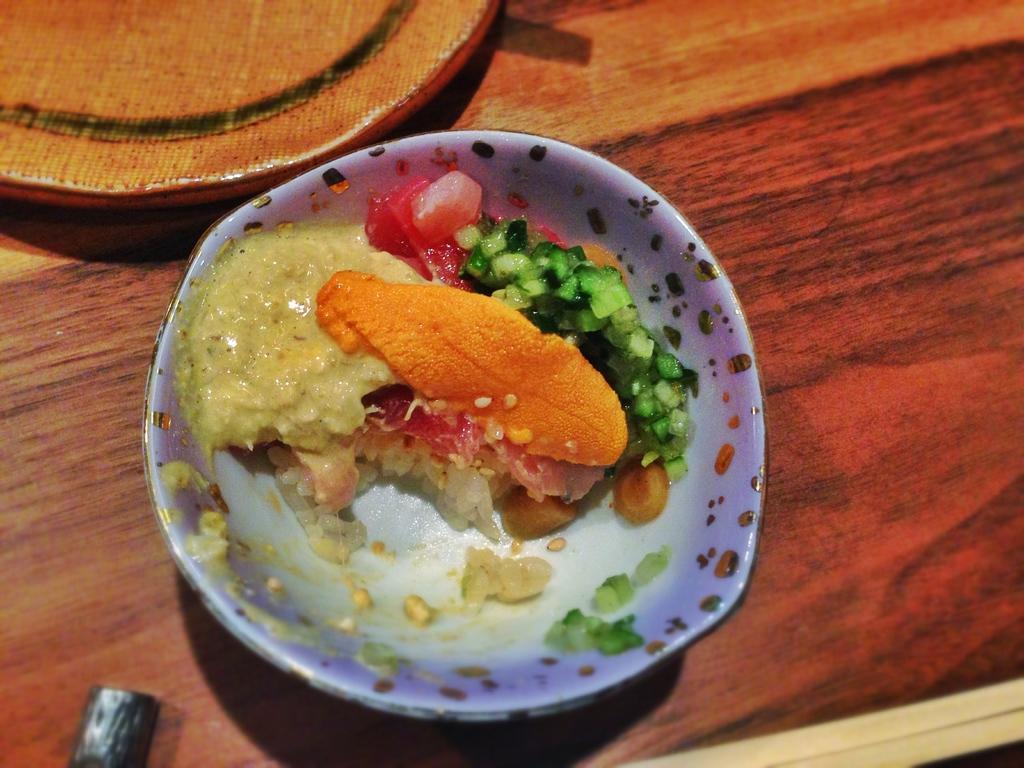Can you describe this image briefly? In this image I can see food which is in red, orange, cream, and green color in the plate and the plate is on the table and the table is brown color. 